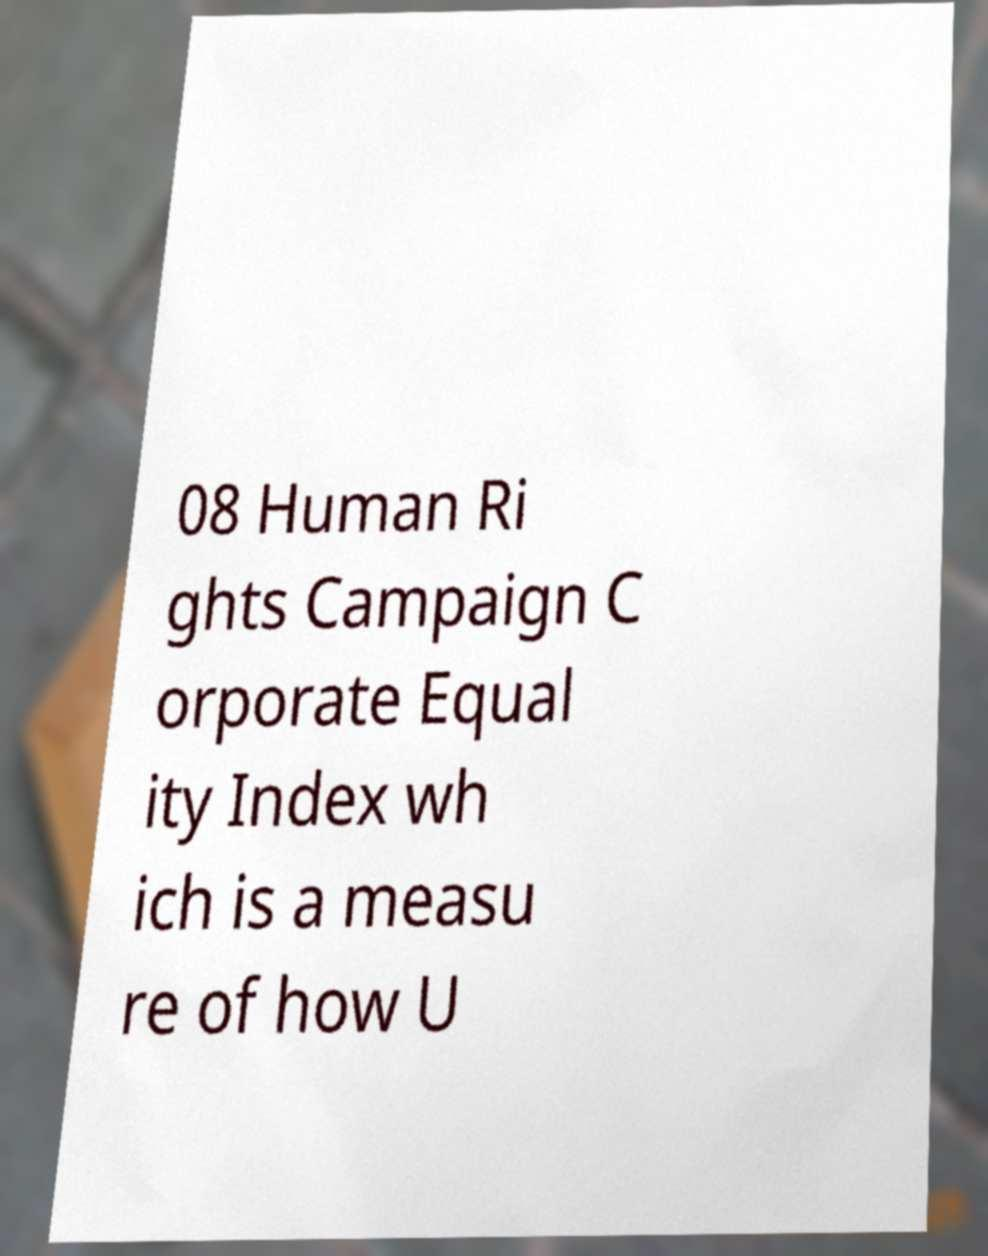Please identify and transcribe the text found in this image. 08 Human Ri ghts Campaign C orporate Equal ity Index wh ich is a measu re of how U 